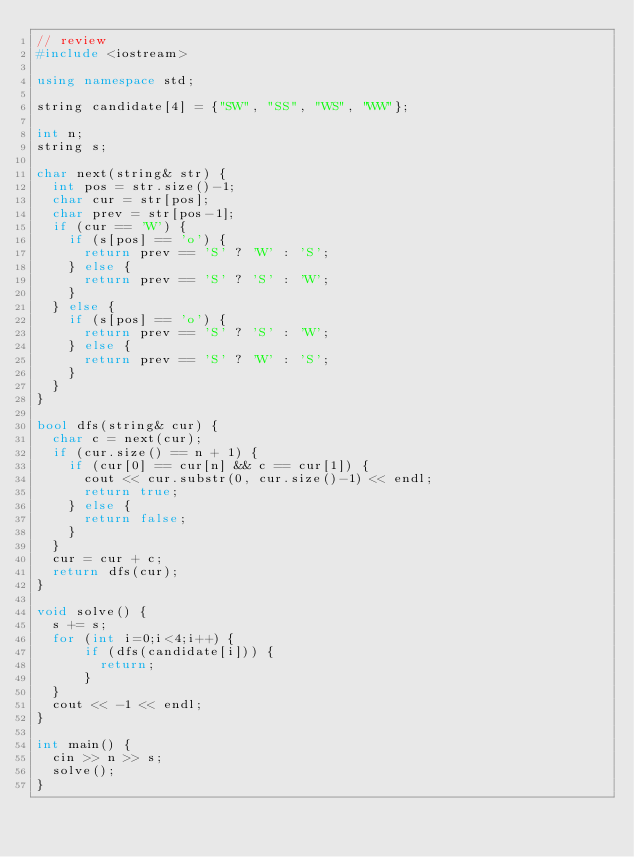Convert code to text. <code><loc_0><loc_0><loc_500><loc_500><_C++_>// review
#include <iostream>

using namespace std;

string candidate[4] = {"SW", "SS", "WS", "WW"};

int n;
string s;

char next(string& str) {
  int pos = str.size()-1;
  char cur = str[pos];
  char prev = str[pos-1];
  if (cur == 'W') {
    if (s[pos] == 'o') {
      return prev == 'S' ? 'W' : 'S';
    } else {
      return prev == 'S' ? 'S' : 'W';
    }
  } else {
    if (s[pos] == 'o') {
      return prev == 'S' ? 'S' : 'W';
    } else {
      return prev == 'S' ? 'W' : 'S';
    }
  }
}

bool dfs(string& cur) {
  char c = next(cur);
  if (cur.size() == n + 1) {
    if (cur[0] == cur[n] && c == cur[1]) {
      cout << cur.substr(0, cur.size()-1) << endl;
      return true;
    } else {
      return false;
    }
  }
  cur = cur + c;
  return dfs(cur);
}

void solve() {
  s += s;
  for (int i=0;i<4;i++) {
      if (dfs(candidate[i])) {
        return;
      }
  }
  cout << -1 << endl;
}

int main() {
  cin >> n >> s;
  solve();
}
</code> 